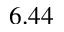<formula> <loc_0><loc_0><loc_500><loc_500>6 . 4 4</formula> 